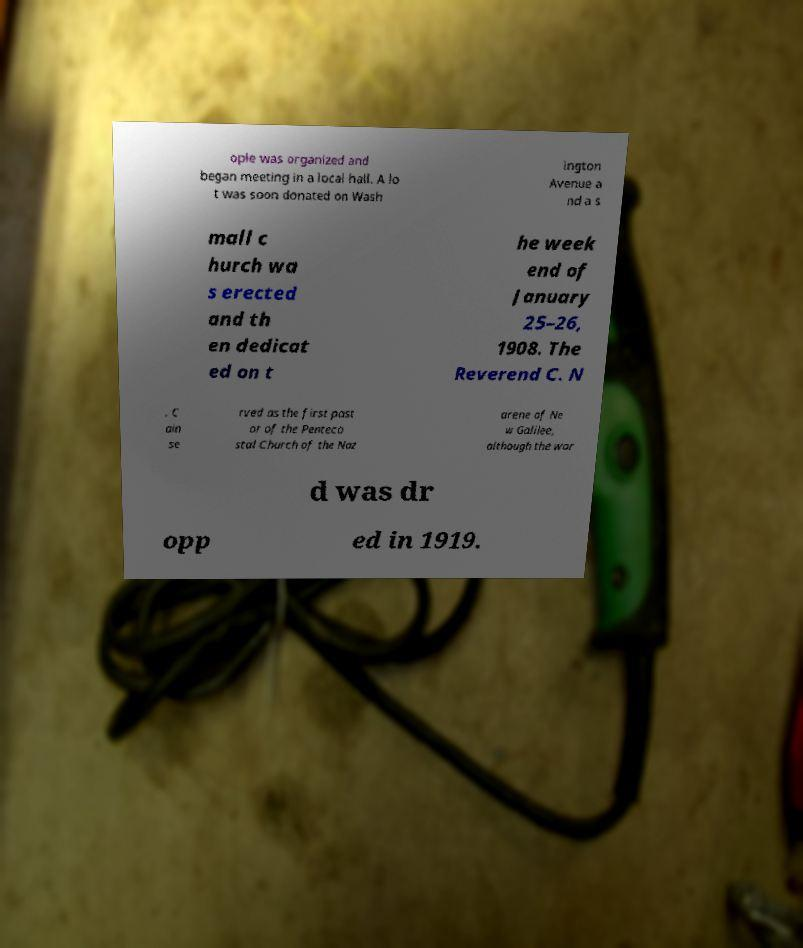Please read and relay the text visible in this image. What does it say? ople was organized and began meeting in a local hall. A lo t was soon donated on Wash ington Avenue a nd a s mall c hurch wa s erected and th en dedicat ed on t he week end of January 25–26, 1908. The Reverend C. N . C ain se rved as the first past or of the Penteco stal Church of the Naz arene of Ne w Galilee, although the wor d was dr opp ed in 1919. 